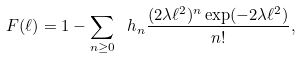<formula> <loc_0><loc_0><loc_500><loc_500>\ F ( \ell ) = 1 - \sum _ { n \geq 0 } \ h _ { n } \frac { ( 2 \lambda \ell ^ { 2 } ) ^ { n } \exp ( - 2 \lambda \ell ^ { 2 } ) } { n ! } ,</formula> 